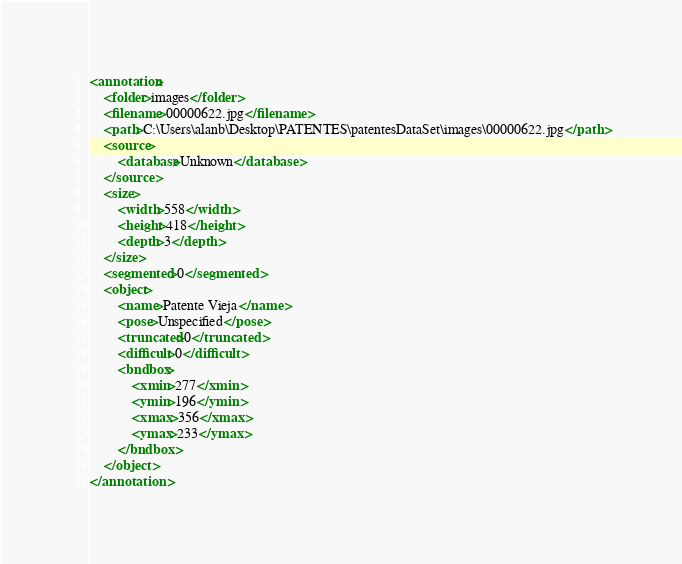<code> <loc_0><loc_0><loc_500><loc_500><_XML_><annotation>
	<folder>images</folder>
	<filename>00000622.jpg</filename>
	<path>C:\Users\alanb\Desktop\PATENTES\patentesDataSet\images\00000622.jpg</path>
	<source>
		<database>Unknown</database>
	</source>
	<size>
		<width>558</width>
		<height>418</height>
		<depth>3</depth>
	</size>
	<segmented>0</segmented>
	<object>
		<name>Patente Vieja</name>
		<pose>Unspecified</pose>
		<truncated>0</truncated>
		<difficult>0</difficult>
		<bndbox>
			<xmin>277</xmin>
			<ymin>196</ymin>
			<xmax>356</xmax>
			<ymax>233</ymax>
		</bndbox>
	</object>
</annotation>
</code> 